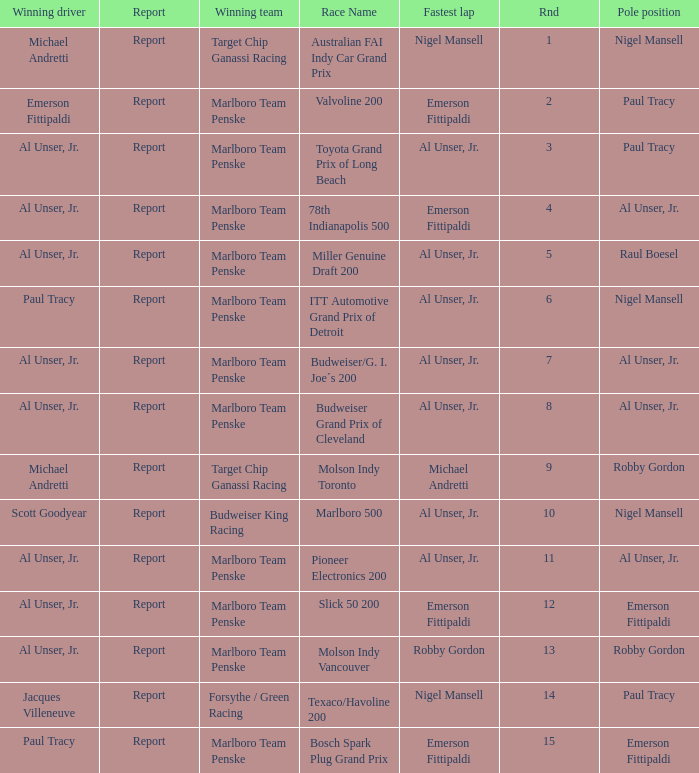Who was on the pole position in the Texaco/Havoline 200 race? Paul Tracy. 